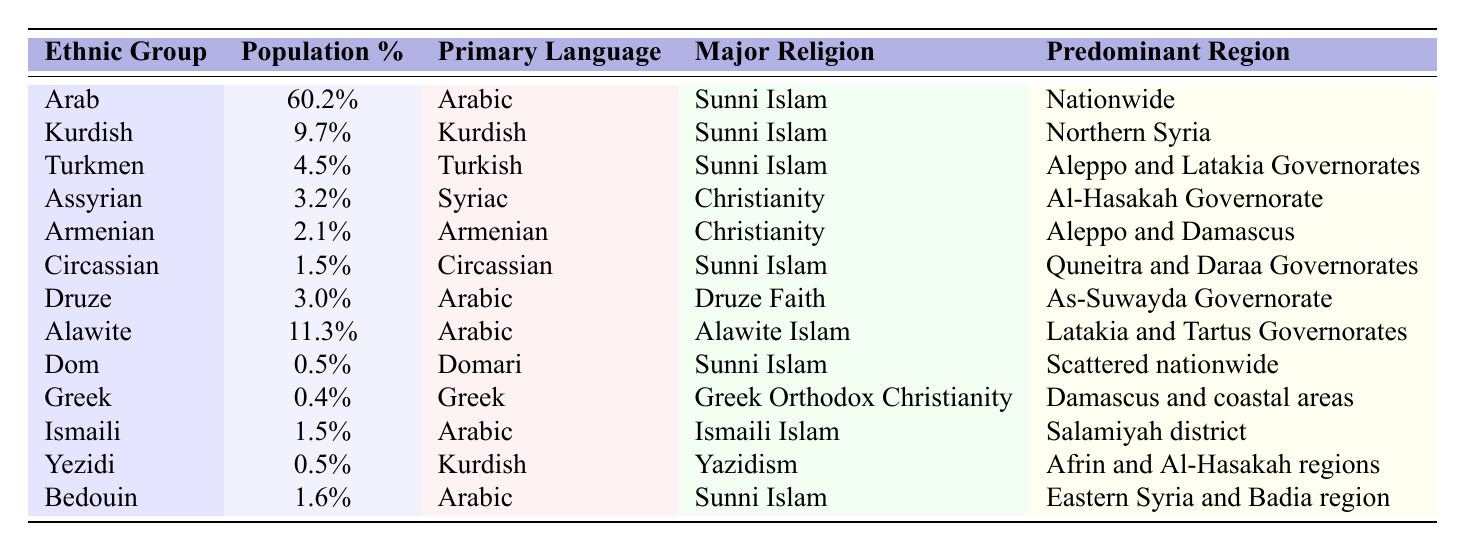What is the percentage of the Arab ethnic group in Syria? The table lists the percentage of the Arab ethnic group as 60.2%.
Answer: 60.2% Which ethnic group has the smallest population percentage? The Dom ethnic group has the smallest population percentage at 0.5%.
Answer: Dom How many ethnic groups have a majority of Sunni Islam followers? By reviewing the major religious affiliation column, the groups are Arab, Kurdish, Turkmen, Circassian, and Bedouin. In total, there are five ethnic groups.
Answer: 5 What is the predominant region for the Kurdish ethnic group? The table indicates that the predominant region for the Kurdish ethnic group is Northern Syria.
Answer: Northern Syria Are there any ethnic groups that have a primary language of Kurdish? Yes, both the Kurdish and Yezidi ethnic groups have Kurdish as their primary language.
Answer: Yes What is the combined percentage of the Assyrian and Armenian ethnic groups? Adding the percentages of Assyrian (3.2%) and Armenian (2.1%) gives us 3.2% + 2.1% = 5.3%.
Answer: 5.3% Which ethnic group primarily speaks Syriac? The Assyrian ethnic group primarily speaks Syriac, as indicated in the primary language column.
Answer: Assyrian Do any ethnic groups in Syria practice a faith other than Islam or Christianity? Yes, the Druze Faith and Yazidism are practiced by the Druze and Yezidi ethnic groups, respectively.
Answer: Yes Which ethnic group has the largest presence in Aleppo and Latakia Governorates? The Turkmen ethnic group has a notable presence in the Aleppo and Latakia Governorates, as mentioned in the table.
Answer: Turkmen What is the percentage of the Alawite ethnic group? The percentage of the Alawite ethnic group is 11.3%.
Answer: 11.3% How many ethnic groups have a percentage of population below 3%? The ethnic groups with a percentage below 3% are Dom (0.5%), Greek (0.4%), and Yezidi (0.5%), totaling three groups.
Answer: 3 Are there any groups that are primarily located nationwide? Yes, the Arab ethnic group is mentioned as having a nationwide presence.
Answer: Yes 